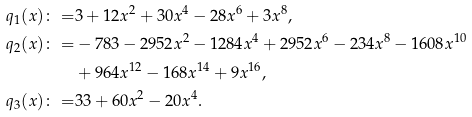<formula> <loc_0><loc_0><loc_500><loc_500>q _ { 1 } ( x ) \colon = & 3 + 1 2 x ^ { 2 } + 3 0 x ^ { 4 } - 2 8 x ^ { 6 } + 3 x ^ { 8 } , \\ q _ { 2 } ( x ) \colon = & - 7 8 3 - 2 9 5 2 x ^ { 2 } - 1 2 8 4 x ^ { 4 } + 2 9 5 2 x ^ { 6 } - 2 3 4 x ^ { 8 } - 1 6 0 8 x ^ { 1 0 } \\ & + 9 6 4 x ^ { 1 2 } - 1 6 8 x ^ { 1 4 } + 9 x ^ { 1 6 } , \\ q _ { 3 } ( x ) \colon = & 3 3 + 6 0 x ^ { 2 } - 2 0 x ^ { 4 } .</formula> 